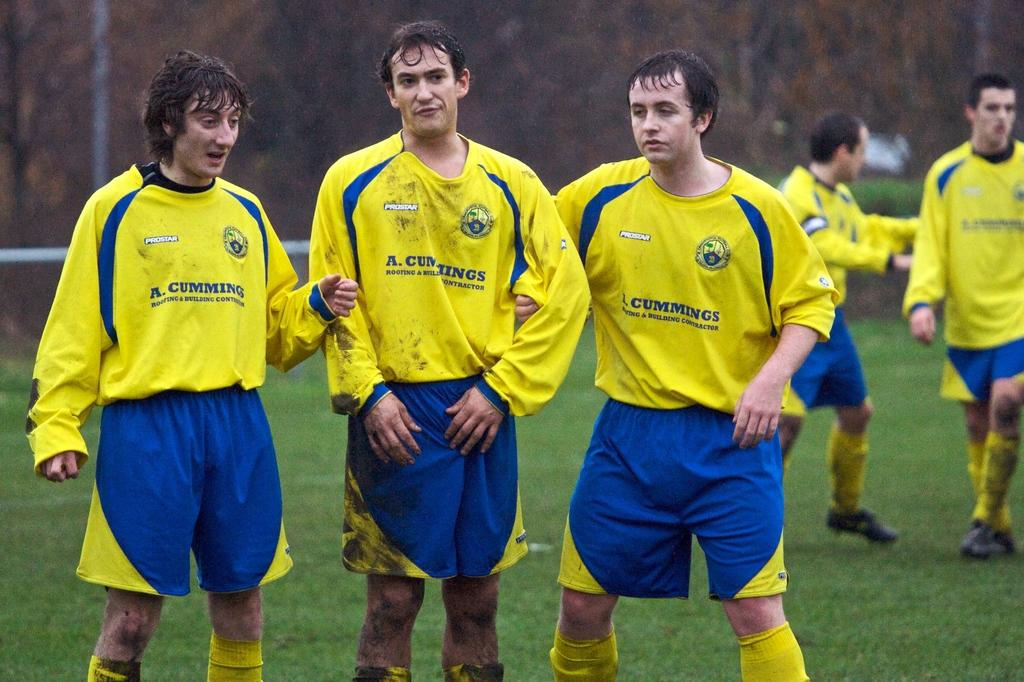What type of people can be seen in the image? There are sports persons in the image. What are the sports persons doing in the image? The sports persons are talking to each other. What is the setting of the image? There is a playground in the image. What type of metal can be seen in the eyes of the sports persons in the image? There is no metal or any reference to eyes in the image; it only shows sports persons talking to each other on a playground. 